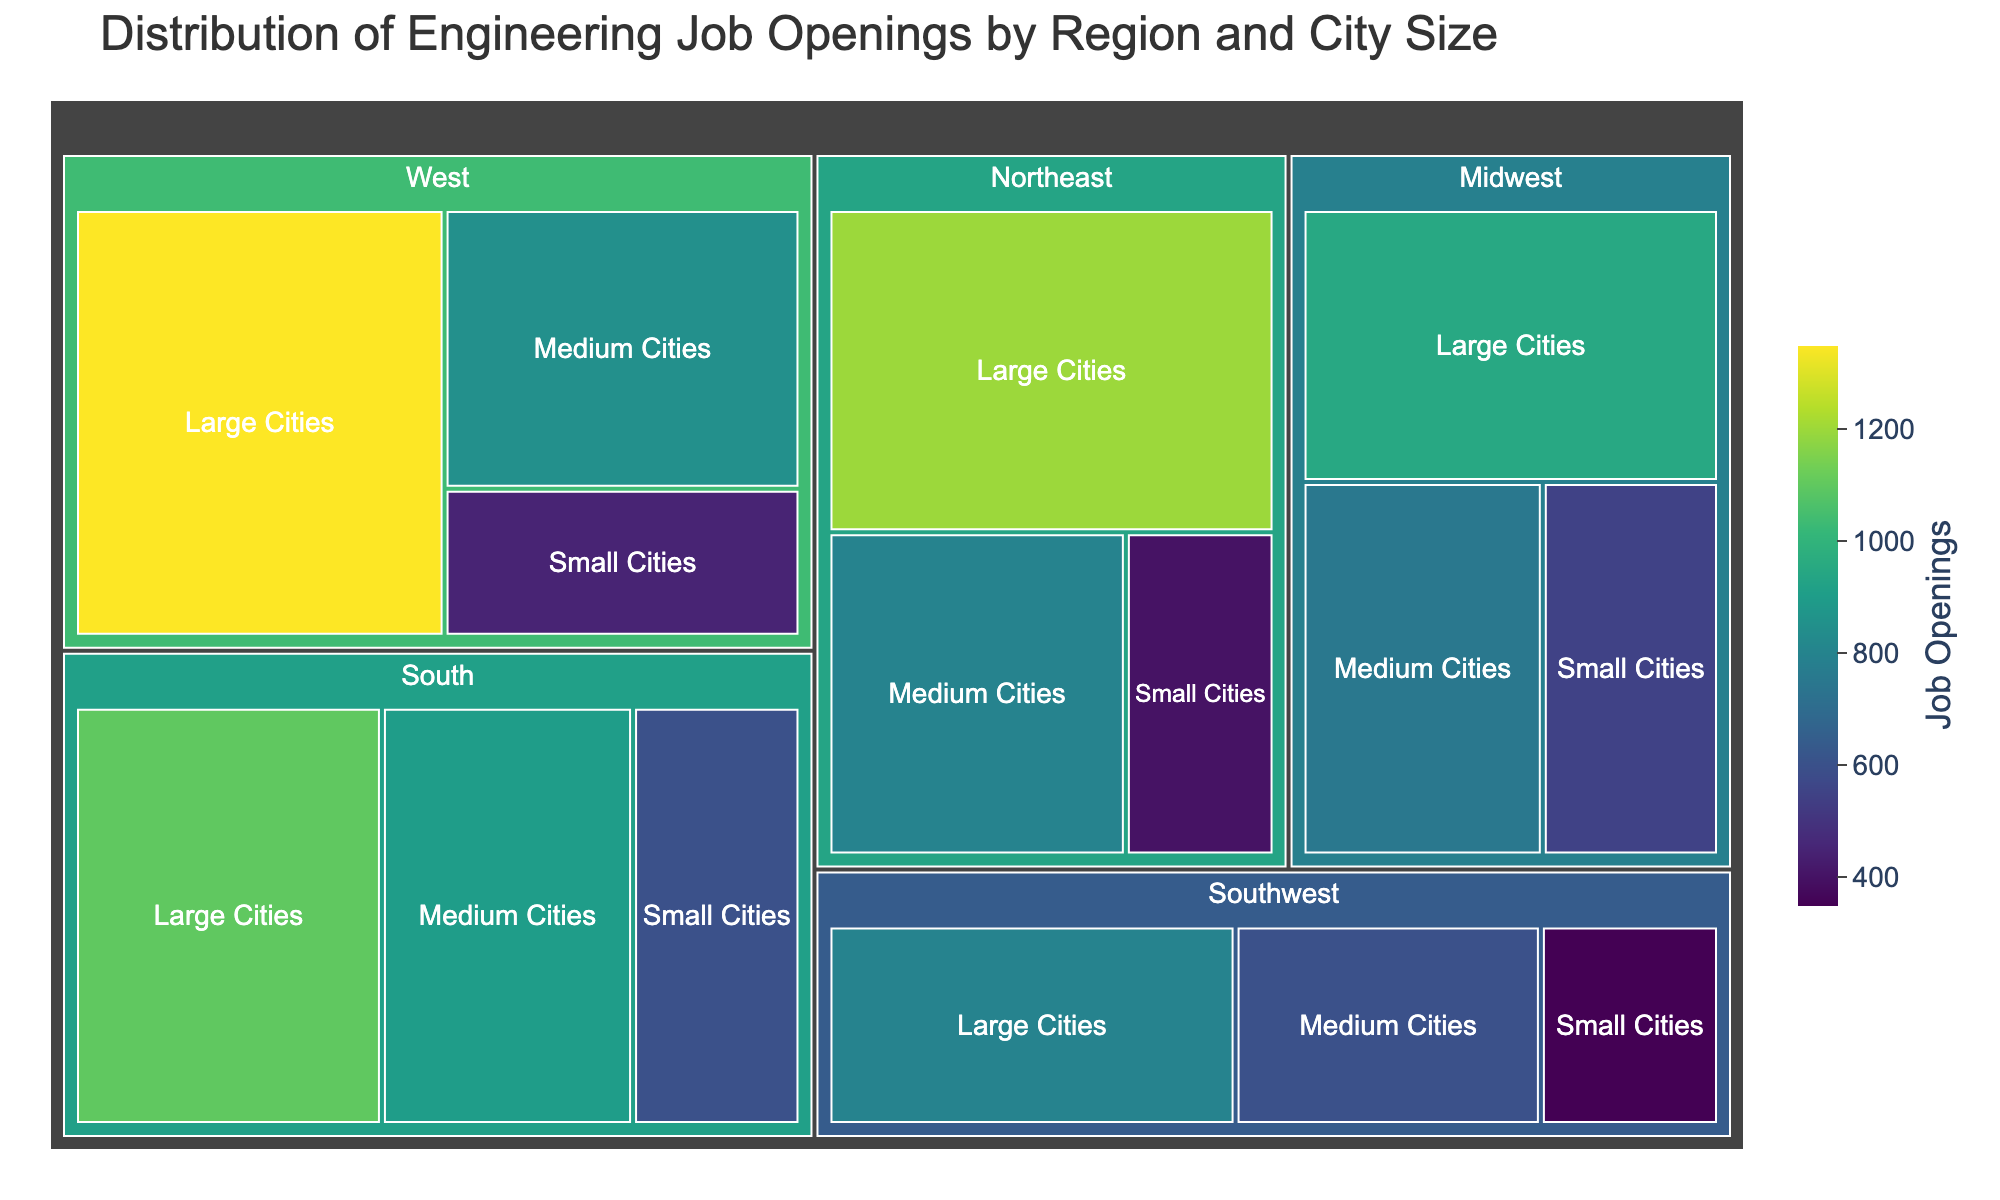What is the total number of job openings in large cities across all regions? First, identify the job openings in large cities from all regions: Northeast (1200), Midwest (950), South (1100), West (1350), and Southwest (800). Sum these values: 1200 + 950 + 1100 + 1350 + 800.
Answer: 5400 Which region has the highest number of job openings in small cities? Look at the job openings in small cities for each region: Northeast (400), Midwest (550), South (600), West (450), and Southwest (350). Compare these numbers to find the highest one, which is in the South.
Answer: South How many more job openings are there in medium cities in the South compared to the Southwest? Identify job openings in medium cities for both South (900) and Southwest (600). Then subtract the Southwest's value from the South's: 900 - 600.
Answer: 300 What is the average number of job openings across medium cities in all regions? Collect the job openings in medium cities: Northeast (800), Midwest (750), South (900), West (850), Southwest (600). Sum these values: 800 + 750 + 900 + 850 + 600 = 3900. Divide by the number of regions (5): 3900 / 5.
Answer: 780 Which region has the least number of job openings in total? Compute the total job openings for each region:
Northeast: 1200 + 800 + 400 = 2400
Midwest: 950 + 750 + 550 = 2250
South: 1100 + 900 + 600 = 2600
West: 1350 + 850 + 450 = 2650
Southwest: 800 + 600 + 350 = 1750
Compare these sums and find that the Southwest has the least total job openings.
Answer: Southwest What is the difference between the job openings in large cities in the West and the Midwest? Identify job openings in large cities for West (1350) and Midwest (950). Subtract the Midwest value from the West value: 1350 - 950.
Answer: 400 Which city size in the Northeast has the least job openings? Identify job openings in the Northeast for each city size: Large Cities (1200), Medium Cities (800), Small Cities (400). The smallest number is for Small Cities.
Answer: Small Cities How does the number of job openings in the Midwest's large cities compare to the Northeast's large cities? Compare the job openings in large cities: Midwest (950), Northeast (1200). The Northeast has more openings than the Midwest.
Answer: Northeast has more What proportion of total job openings in the South are in medium cities? First, compute the total job openings in the South: 1100 + 900 + 600 = 2600. The number of openings in medium cities is 900. Calculate the proportion: 900 / 2600. Multiply by 100 to get a percentage: (900 / 2600) * 100.
Answer: Approximately 34.62% 